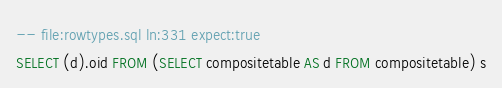Convert code to text. <code><loc_0><loc_0><loc_500><loc_500><_SQL_>-- file:rowtypes.sql ln:331 expect:true
SELECT (d).oid FROM (SELECT compositetable AS d FROM compositetable) s
</code> 